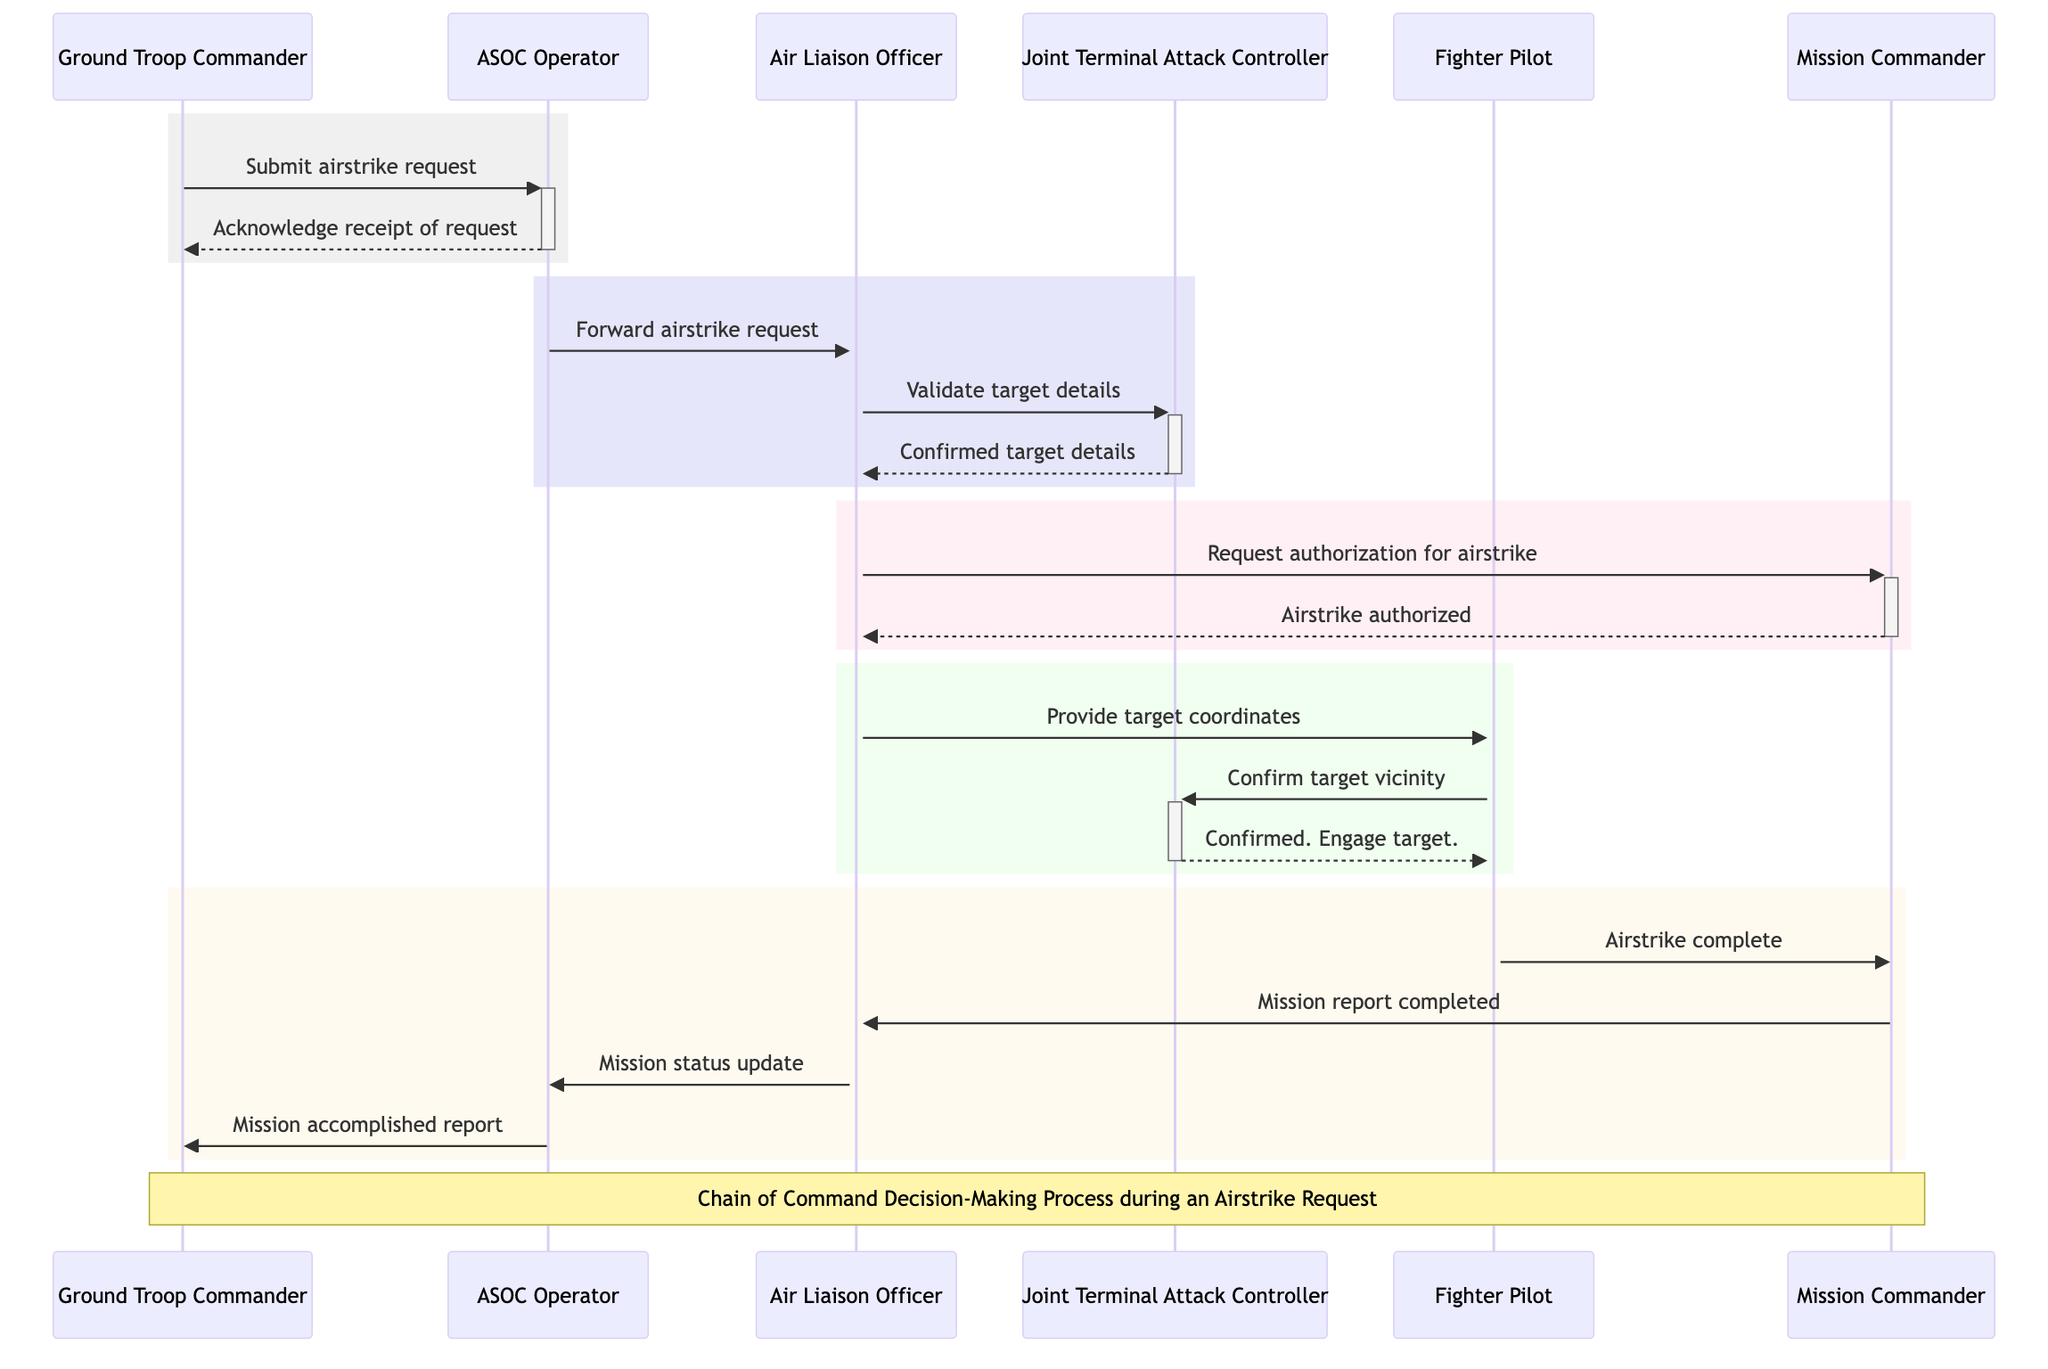What role does the Ground Troop Commander play? The Ground Troop Commander initiates the airstrike request, marking the beginning of the process depicted in the diagram.
Answer: Initiates request for airstrike How many messages are sent from the Air Liaison Officer to the Fighter Pilot? The diagram shows that the Air Liaison Officer sends one message to the Fighter Pilot, which provides target coordinates.
Answer: One What confirmation does the Joint Terminal Attack Controller provide to the Fighter Pilot? The Joint Terminal Attack Controller confirms target vicinity and instructs the Fighter Pilot to engage the target, showcasing a critical step for execution.
Answer: Confirmed. Engage target Who must authorize the airstrike? The Mission Commander is responsible for overseeing and authorizing the airstrike, indicating that their approval is necessary for proceeding with the request.
Answer: Mission Commander What happens after the Fighter Pilot completes the airstrike? After the airstrike is completed, the Fighter Pilot sends a message to the Mission Commander reporting that the airstrike is complete, which is followed by mission reporting and updates.
Answer: Airstrike complete What is the sequence of actors involved in validating the airstrike request? The sequence begins with the Air Liaison Officer forwarding the airstrike request to the Joint Terminal Attack Controller, who then validates and confirms the target details.
Answer: ALO to JTAC How many participants are involved in the airstrike request process? The diagram highlights six distinct participants involved in the airstrike request process, each playing a specific role throughout the sequence.
Answer: Six What is the purpose of the ASOC Operator in this diagram? The ASOC Operator serves the key role of receiving, logging, and forwarding the airstrike request, functioning as a pivotal communication link in the chain of command.
Answer: Receives and logs the airstrike request Who delivers the mission status update at the end of the airstrike process? The Air Liaison Officer communicates the mission status update to the ASOC Operator, illustrating the final step in maintaining situational awareness after the strike.
Answer: Air Liaison Officer 